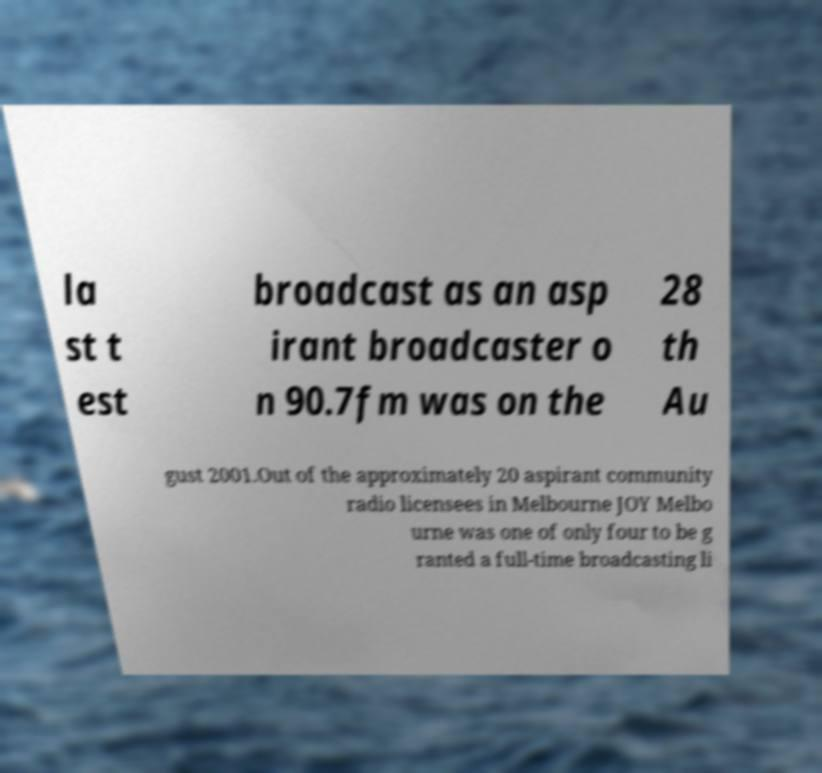Can you read and provide the text displayed in the image?This photo seems to have some interesting text. Can you extract and type it out for me? la st t est broadcast as an asp irant broadcaster o n 90.7fm was on the 28 th Au gust 2001.Out of the approximately 20 aspirant community radio licensees in Melbourne JOY Melbo urne was one of only four to be g ranted a full-time broadcasting li 